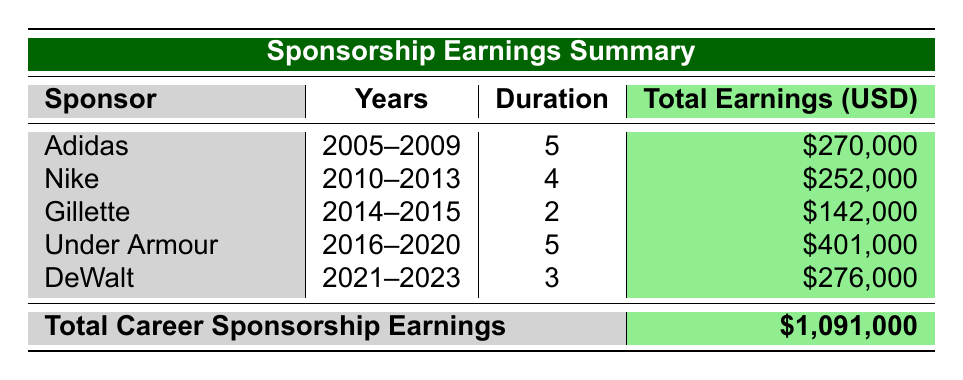What is the total earnings from Adidas sponsorship? The table shows that Adidas earned a total of $270,000 over 5 years (2005 to 2009).
Answer: $270,000 Which sponsor had the longest duration of earnings? Adidas and Under Armour both had a duration of 5 years, which is the longest in the table.
Answer: Adidas and Under Armour What was the average annual earnings from Nike? Nike's total earnings are $252,000 over 4 years (2010 to 2013), so the average annual earnings are $252,000 / 4 = $63,000.
Answer: $63,000 Did Gillette sponsor create more earnings than Nike? Gillette earned $142,000 over 2 years, while Nike earned $252,000 over 4 years. $142,000 is less than $252,000.
Answer: No What sponsor generated the highest total earnings? By inspecting the total earnings, Under Armour generated the highest total at $401,000, compared to others.
Answer: Under Armour What is the combined total earnings from sponsorships in the years 2021 to 2023? The total earnings from DeWalt in those years are $90000 + $92000 + $94000 = $276000.
Answer: $276,000 If you rank the sponsors by their total earnings, which sponsor comes second? The total earnings are: Under Armour ($401,000), DeWalt ($276,000), Adidas ($270,000), Nike ($252,000), and Gillette ($142,000). Hence, DeWalt comes second.
Answer: DeWalt Was the total earnings from Gillette greater than the total earnings from Adidas? Gillette earned $142,000 while Adidas earned $270,000. Since $142,000 is less than $270,000, the answer is no.
Answer: No How many total sponsorships did Peter Trevitt have during his career? The table lists five sponsors: Adidas, Nike, Gillette, Under Armour, and DeWalt. Therefore, Peter had five sponsors.
Answer: 5 